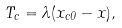<formula> <loc_0><loc_0><loc_500><loc_500>T _ { c } = \lambda ( x _ { c 0 } - x ) ,</formula> 